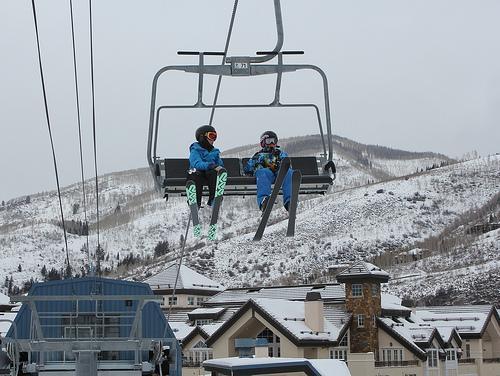How many people are in the picture?
Give a very brief answer. 2. 